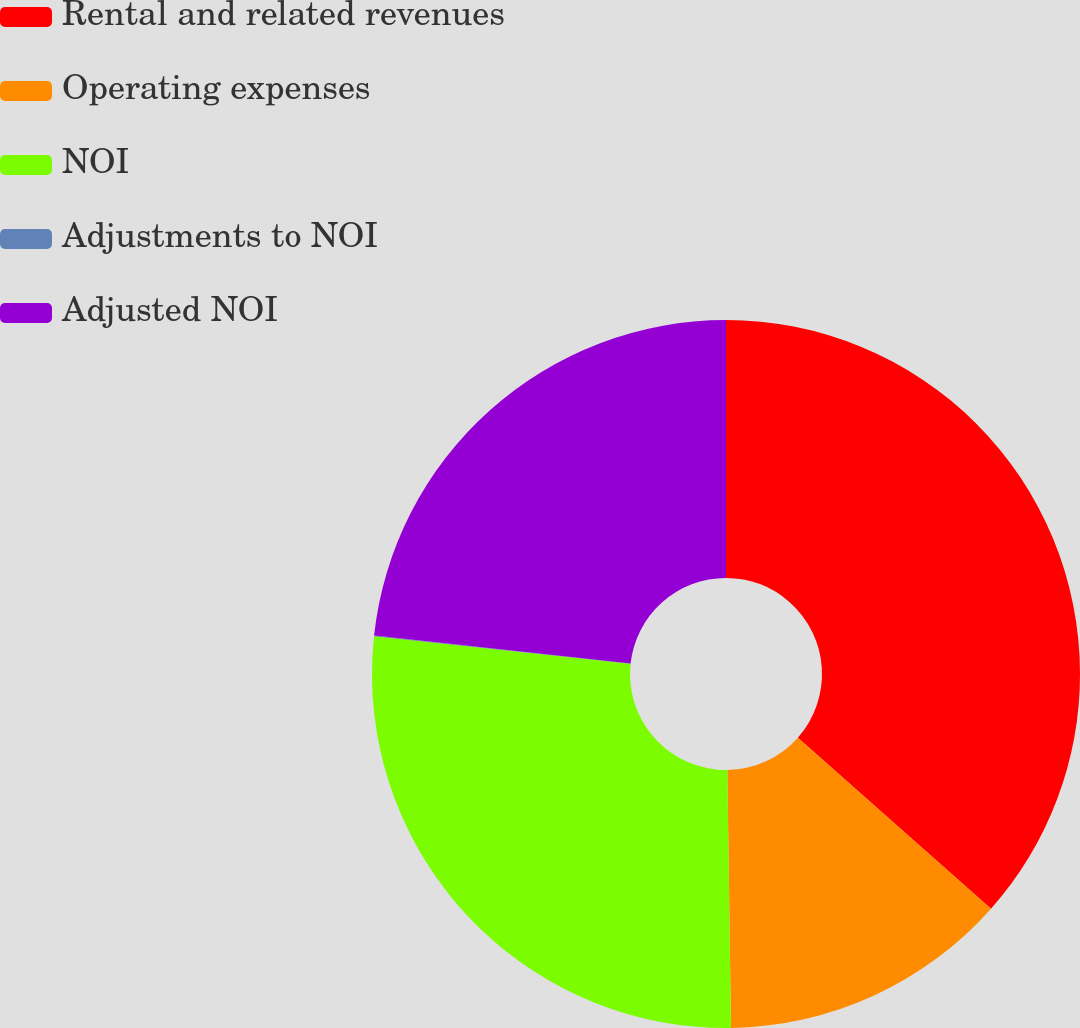<chart> <loc_0><loc_0><loc_500><loc_500><pie_chart><fcel>Rental and related revenues<fcel>Operating expenses<fcel>NOI<fcel>Adjustments to NOI<fcel>Adjusted NOI<nl><fcel>36.54%<fcel>13.24%<fcel>26.93%<fcel>0.03%<fcel>23.27%<nl></chart> 